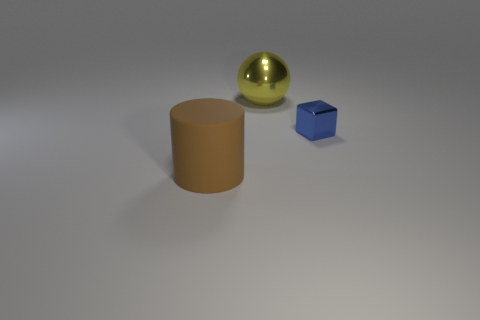Add 2 tiny metal objects. How many objects exist? 5 Subtract all gray cubes. Subtract all brown cylinders. How many cubes are left? 1 Subtract all spheres. How many objects are left? 2 Subtract all tiny metal objects. Subtract all large purple rubber objects. How many objects are left? 2 Add 1 metallic cubes. How many metallic cubes are left? 2 Add 1 large gray matte blocks. How many large gray matte blocks exist? 1 Subtract 0 brown blocks. How many objects are left? 3 